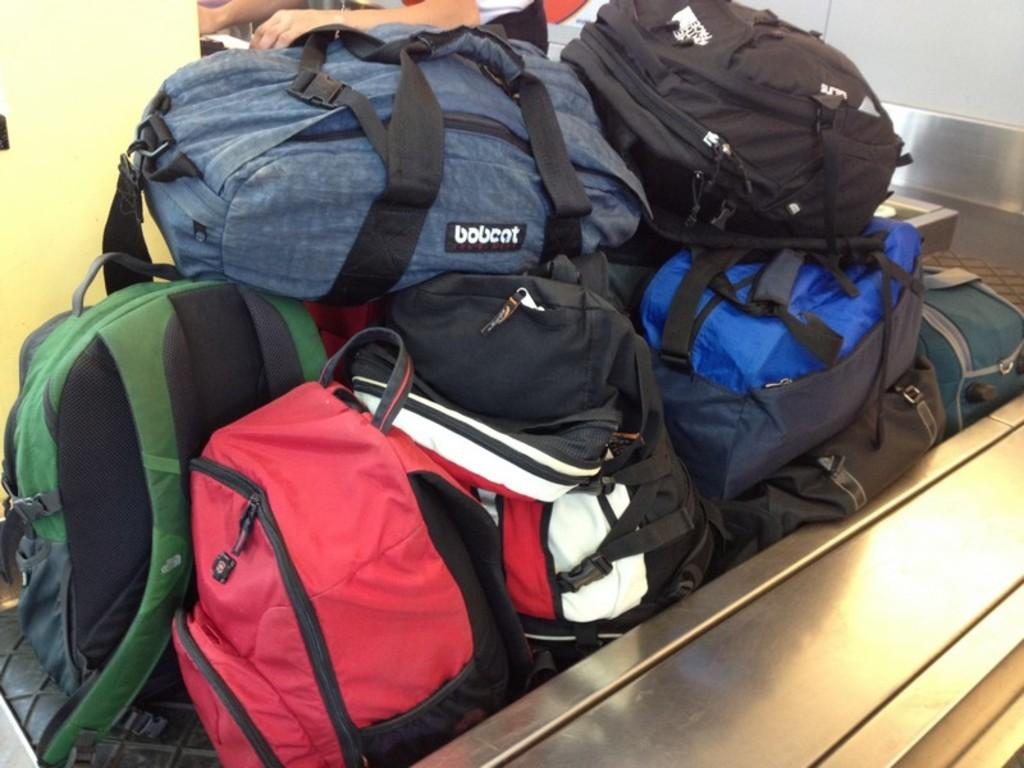What objects are in the front of the image? There are bags in the front of the image. Can you describe the position of the bags in the image? The bags are in the front of the image. Are there any people visible in the image? Yes, there are two people's hands visible in the background of the image. What type of coat is being worn by the person in the image? There is no person or coat visible in the image; only bags and two people's hands are present. 